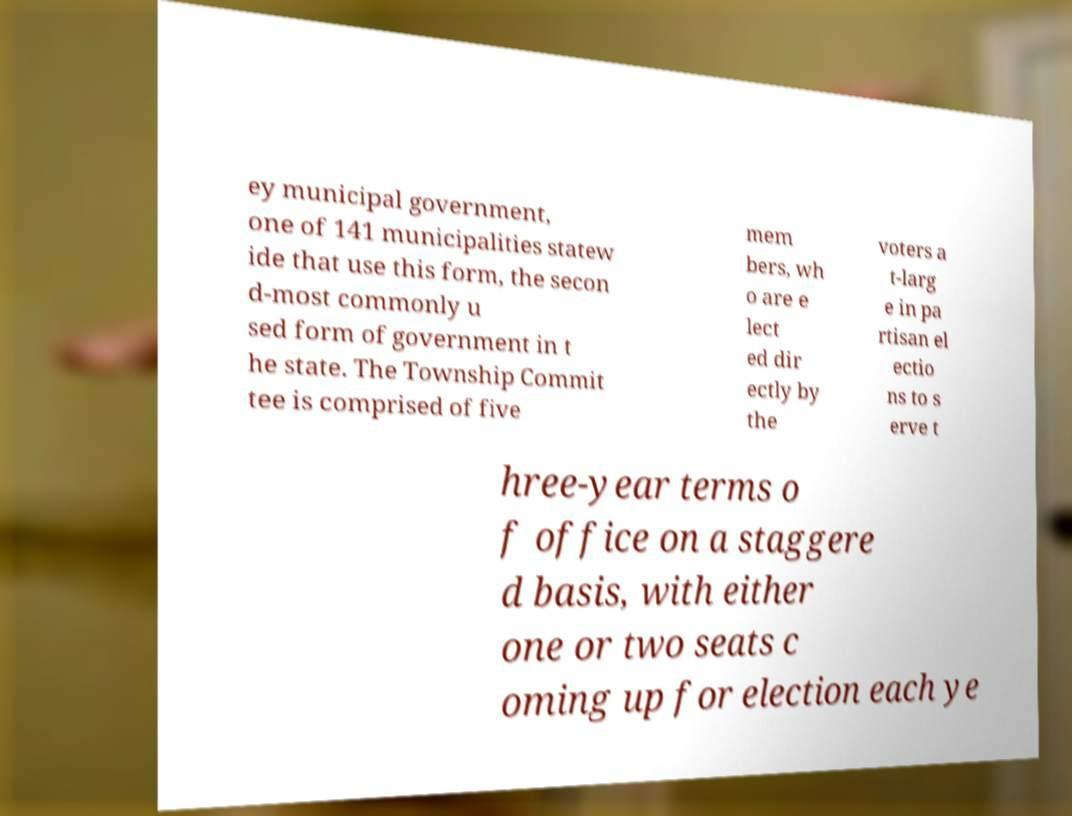Could you assist in decoding the text presented in this image and type it out clearly? ey municipal government, one of 141 municipalities statew ide that use this form, the secon d-most commonly u sed form of government in t he state. The Township Commit tee is comprised of five mem bers, wh o are e lect ed dir ectly by the voters a t-larg e in pa rtisan el ectio ns to s erve t hree-year terms o f office on a staggere d basis, with either one or two seats c oming up for election each ye 